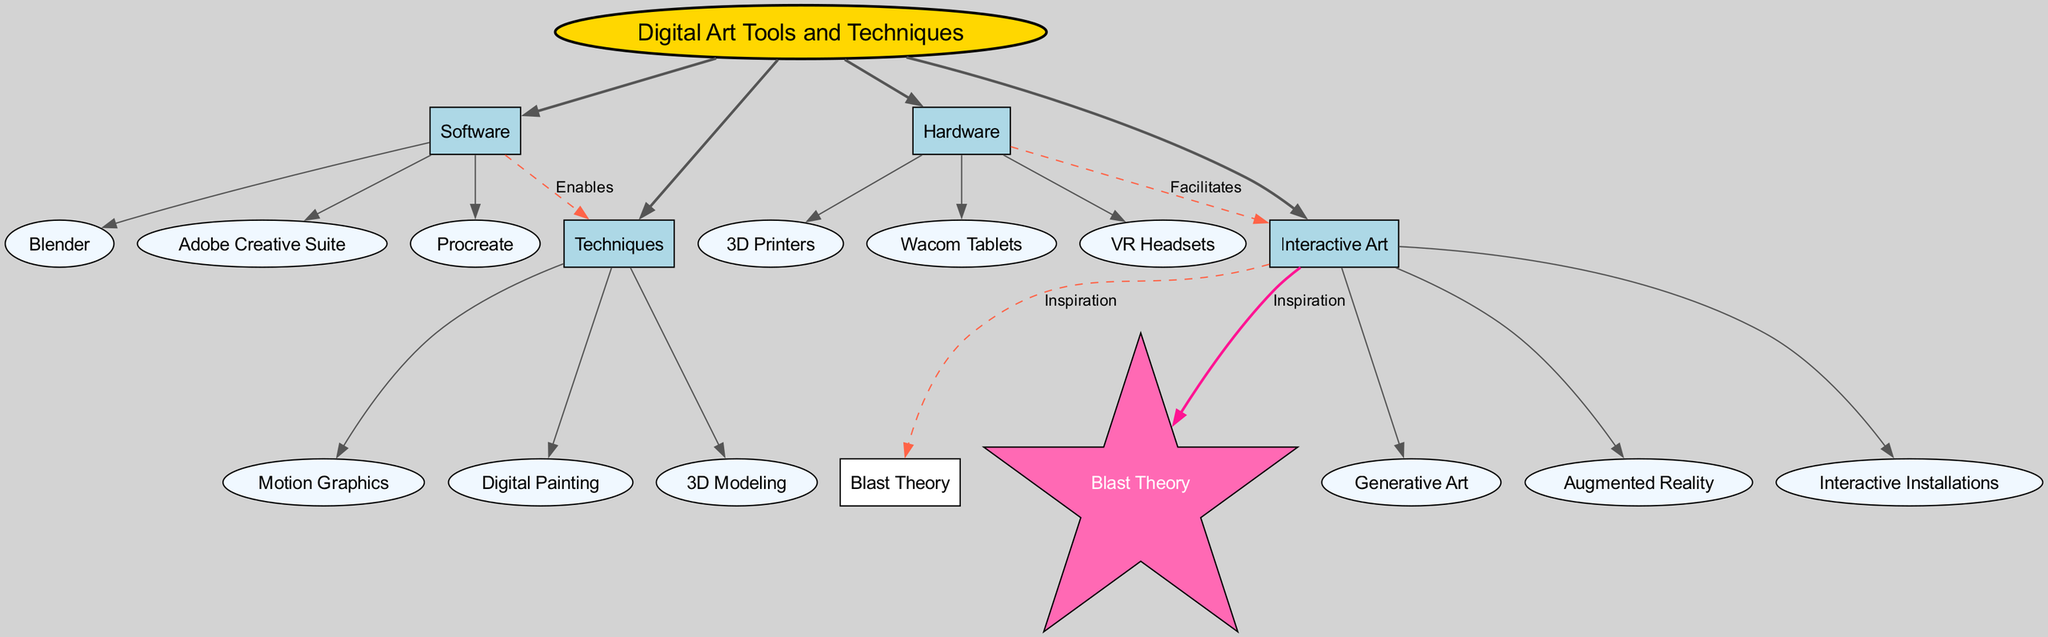What is the central concept of the diagram? The central concept is explicitly stated at the top of the diagram as "Digital Art Tools and Techniques."
Answer: Digital Art Tools and Techniques How many main categories are present in the diagram? There are four main categories listed under "Digital Art Tools and Techniques": Software, Hardware, Techniques, and Interactive Art.
Answer: 4 Which category includes "Blender"? "Blender" is listed under the "Software" category as one of the subcategories.
Answer: Software What does "Software" enable in the context of the diagram? The connection labeled "Enables" from "Software" leads to "Techniques," indicating that software enables various techniques in digital art.
Answer: Techniques Which two main categories have a direct connection in the diagram? The "Software" and "Techniques" categories have a direct connection through the "Enables" label, and "Hardware" and "Interactive Art" have a connection labeled "Facilitates."
Answer: Software, Techniques What type of node represents "Blast Theory" in the diagram? "Blast Theory" is represented as a star-shaped node in the diagram, which is designed to stand out among other nodes.
Answer: Star What role does "Hardware" play concerning "Interactive Art"? The diagram's connection shows that "Hardware" facilitates "Interactive Art," indicating that hardware components support the creation and execution of interactive art projects.
Answer: Facilitates How many subcategories are under "Techniques"? Under the "Techniques" category, there are three subcategories listed: Digital Painting, 3D Modeling, and Motion Graphics.
Answer: 3 Which type of art is connected to "Blast Theory"? "Interactive Art" is the category that is connected to "Blast Theory," showcasing its inspiration in this field.
Answer: Interactive Art What color represents the central concept node in the diagram? The central concept node is colored gold (#FFD700), which differentiates it visually from other nodes.
Answer: Gold 